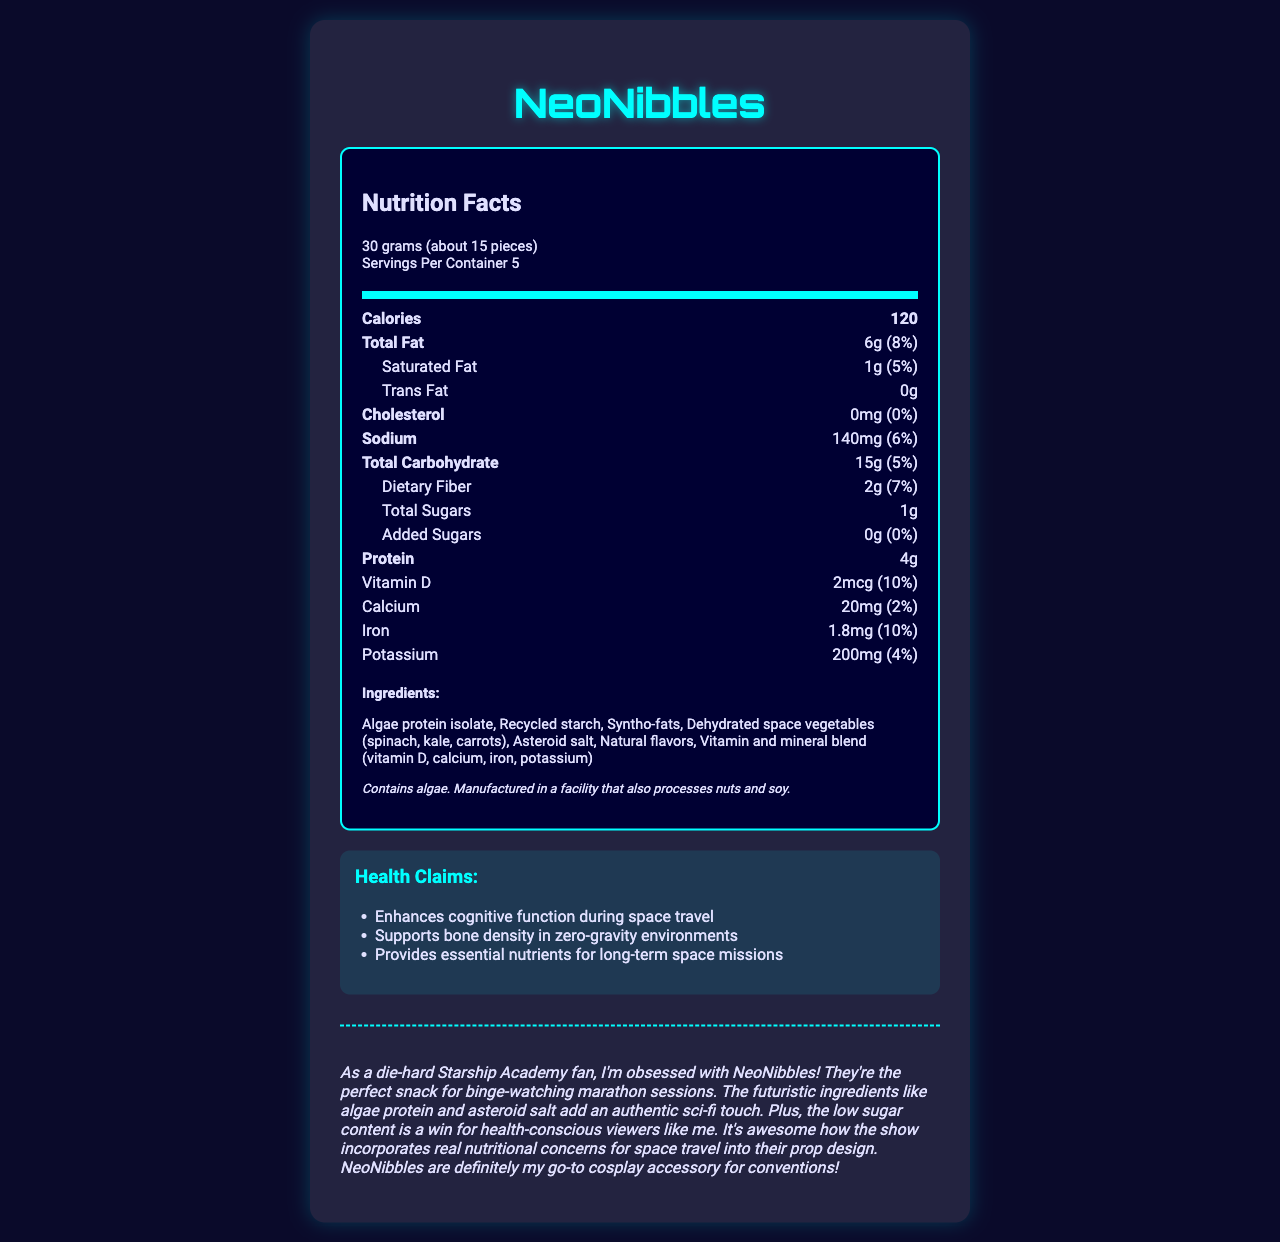What is the serving size for NeoNibbles? The serving size information is listed under the nutrition header and specifies "30 grams (about 15 pieces)".
Answer: 30 grams (about 15 pieces) How many servings are there per container of NeoNibbles? Under the serving information, it specifies that there are "Servings Per Container 5".
Answer: 5 How many total calories are in one serving of NeoNibbles? The calories per serving are explicitly stated as 120 in the document.
Answer: 120 What is the total amount of fat per serving and its daily value percentage? The total fat per serving is shown as 6g, with a daily value of 8%.
Answer: 6g (8%) Which ingredient in NeoNibbles is a source of protein? In the list of ingredients, algae protein isolate is the ingredient that provides protein.
Answer: Algae protein isolate How much dietary fiber is in a serving of NeoNibbles? Dietary fiber content is 2g per serving, with a daily value of 7%.
Answer: 2g (7%) What are the three fictional health claims associated with NeoNibbles? These claims are listed in the health claims section.
Answer: Enhances cognitive function during space travel, Supports bone density in zero-gravity environments, Provides essential nutrients for long-term space missions What is the main enticing feature of NeoNibbles for Starship Academy fans according to the fan opinion? The fan opinion mentions that NeoNibbles are ideal for binge-watching Starship Academy.
Answer: They're the perfect snack for binge-watching marathon sessions. What kind of flavor enhancer is used in NeoNibbles? In the ingredients list, natural flavors are mentioned as one of the components.
Answer: Natural flavors What should people with nut or soy allergies consider when consuming NeoNibbles? The allergen information states that NeoNibbles are made in a facility that processes these allergens.
Answer: Manufactured in a facility that also processes nuts and soy Which nutrients in NeoNibbles have a daily value percentage of 10%? (Choose all that apply) A. Vitamin D B. Iron C. Potassium D. Calcium Both Vitamin D and Iron have daily values of 10%, as specified in their respective sections.
Answer: A. Vitamin D and B. Iron How much added sugars are in one serving of NeoNibbles? The document specifies that there are 0g of added sugars per serving.
Answer: 0g What mineral in the ingredients list might be a reference to space or sci-fi? A. Iron B. Asteroid salt C. Potassium D. Syntho-fats "Asteroid salt" is a creative reference to space, fitting with the sci-fi theme of Starship Academy.
Answer: B. Asteroid salt Do NeoNibbles contain any cholesterol? The cholesterol content is listed as 0mg, indicating that they do not contain any cholesterol.
Answer: No Summarize the Nutrition Facts Label for NeoNibbles. This summary encapsulates the various aspects of the NeoNibbles Nutrition Facts label and relevant additional notes found in the document.
Answer: NeoNibbles appears in the show Starship Academy and is a futuristic snack with a serving size of 30 grams, containing about 15 pieces. Each serving provides 120 calories, 6g of total fat, 2g of dietary fiber, and 4g of protein, among other nutrients. The ingredients include algae protein isolate, recycled starch, and syntho-fats. It offers various health claims related to space travel. Allergen information notes the presence of algae and potential cross-contamination with nuts and soy. Fan opinion highlights their suitability for binge-watching the series. What is the exact protein composition (specific amino acids) in the algae protein isolate used in NeoNibbles? The document does not provide detailed information regarding the specific amino acids contained in the algae protein isolate.
Answer: Cannot be determined 